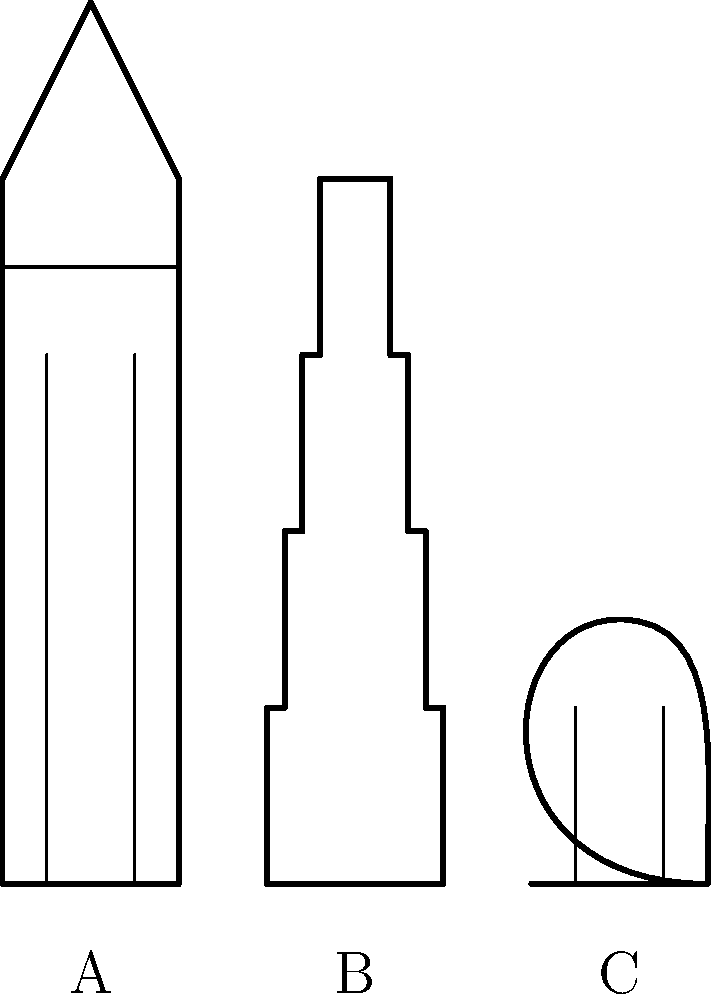As a member of an international crisis negotiation forum, you often encounter situations where understanding cultural differences is crucial. In the context of architectural styles, which of the building outlines (A, B, or C) represents a typical Eastern Asian architectural style that symbolizes harmony with nature and spiritual ascension? To answer this question, let's analyze each building outline:

1. Building A: This outline shows a tall, pointed structure with vertical lines and a triangular top. These are characteristics of Gothic architecture, commonly found in European cathedrals. Gothic architecture emphasizes height and light, symbolizing reaching towards heaven.

2. Building B: This outline depicts a multi-tiered structure with gradually decreasing widths as it goes up. This is typical of a pagoda, an architectural style common in Eastern Asian countries like China, Japan, and Korea. Pagodas are often associated with Buddhist temples and symbolize spiritual ascension and harmony with nature.

3. Building C: This outline shows a rounded top structure, which is characteristic of a dome. Domes are found in various architectural styles worldwide, including Islamic, Renaissance, and Baroque architecture. They often symbolize the heavens or divine authority.

Given the question's focus on Eastern Asian architecture symbolizing harmony with nature and spiritual ascension, the correct answer is Building B, the pagoda. Pagodas are deeply rooted in Eastern Asian culture and Buddhist philosophy, representing the connection between earth and heaven, and the journey of spiritual enlightenment.

Understanding these architectural styles and their cultural significance can be valuable in international negotiations, as it demonstrates respect for and knowledge of different cultural heritages.
Answer: B 